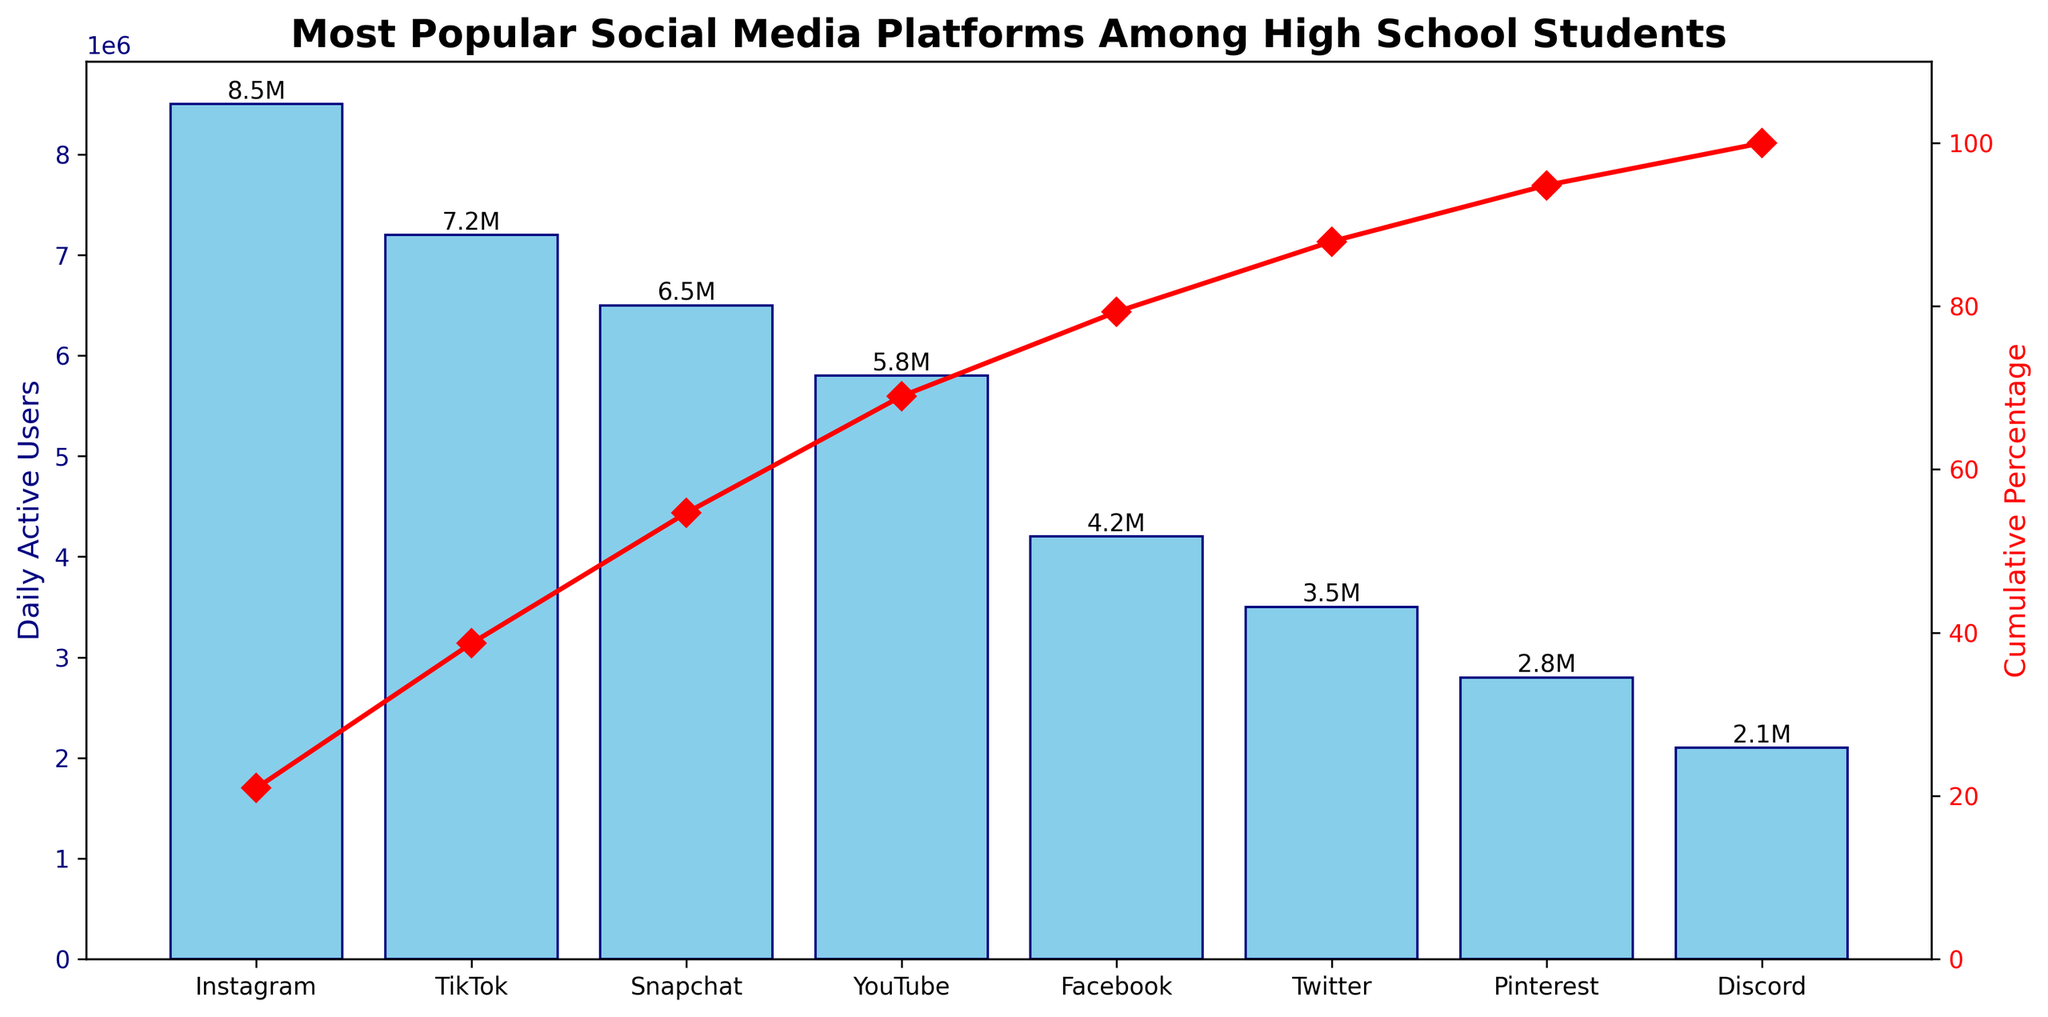What is the most popular social media platform among high school students in terms of daily active users? Look at the bar with the highest value on the y-axis for daily active users. The platform corresponding to this bar is the most popular.
Answer: Instagram How many daily active users does TikTok have? Locate the bar labeled 'TikTok' on the x-axis. Look up to where the top of this bar intersects the y-axis, which represents the number of daily active users.
Answer: 7,200,000 What is the cumulative percentage of daily active users up to Snapchat? Find the point where 'Snapchat' is labeled on the x-axis, then trace upwards to the corresponding point on the red line. This point indicates the cumulative percentage for Snapchat.
Answer: 73.7% Which platform has fewer daily active users, Facebook or Twitter? Compare the heights of the bars labeled 'Facebook' and 'Twitter'. The shorter bar represents the platform with fewer daily active users.
Answer: Twitter What is the combined number of daily active users for Instagram and YouTube? Add the daily active users for Instagram and YouTube as indicated by the heights of their respective bars. Instagram has 8,500,000 users and YouTube has 5,800,000 users, so 8,500,000 + 5,800,000 = 14,300,000.
Answer: 14,300,000 How many platforms have more than 5,000,000 daily active users? Count the number of bars with heights greater than the 5,000,000 mark on the y-axis.
Answer: 4 What is the cumulative percentage after adding Facebook's daily active users? Locate Facebook on the x-axis and trace upwards to the corresponding point on the red cumulative percentage line. This value represents the cumulative percentage up to and including Facebook's users.
Answer: 91.9% Which platform shows the largest drop in daily active users compared to the previous platform in the ranking? Look for the largest vertical gap between the top of one bar and the base of the next bar in descending order from left to right.
Answer: YouTube How much more popular is Instagram compared to Discord in terms of daily active users? Subtract the number of daily active users for Discord from Instagram. Instagram has 8,500,000 users and Discord has 2,100,000 users, so 8,500,000 - 2,100,000 = 6,400,000.
Answer: 6,400,000 What percentage of daily active users does Pinterest contribute out of the total? Find Pinterest's daily active users (2,800,000) and divide by the total daily active users. Sum all users to get the total, then (2,800,000 / 41,900,000) * 100. The total is calculated from the sum of all platforms' daily active users.
Answer: 6.7% 